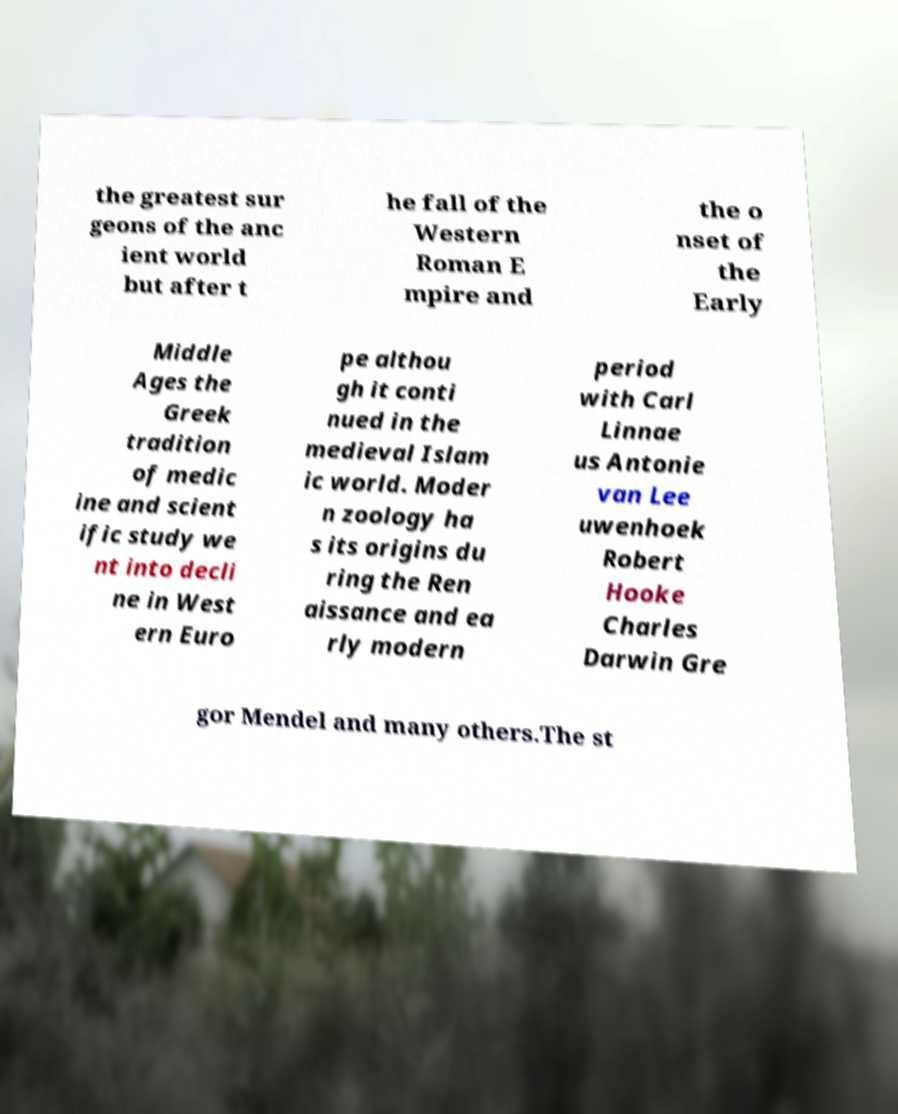Please identify and transcribe the text found in this image. the greatest sur geons of the anc ient world but after t he fall of the Western Roman E mpire and the o nset of the Early Middle Ages the Greek tradition of medic ine and scient ific study we nt into decli ne in West ern Euro pe althou gh it conti nued in the medieval Islam ic world. Moder n zoology ha s its origins du ring the Ren aissance and ea rly modern period with Carl Linnae us Antonie van Lee uwenhoek Robert Hooke Charles Darwin Gre gor Mendel and many others.The st 